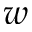<formula> <loc_0><loc_0><loc_500><loc_500>w</formula> 